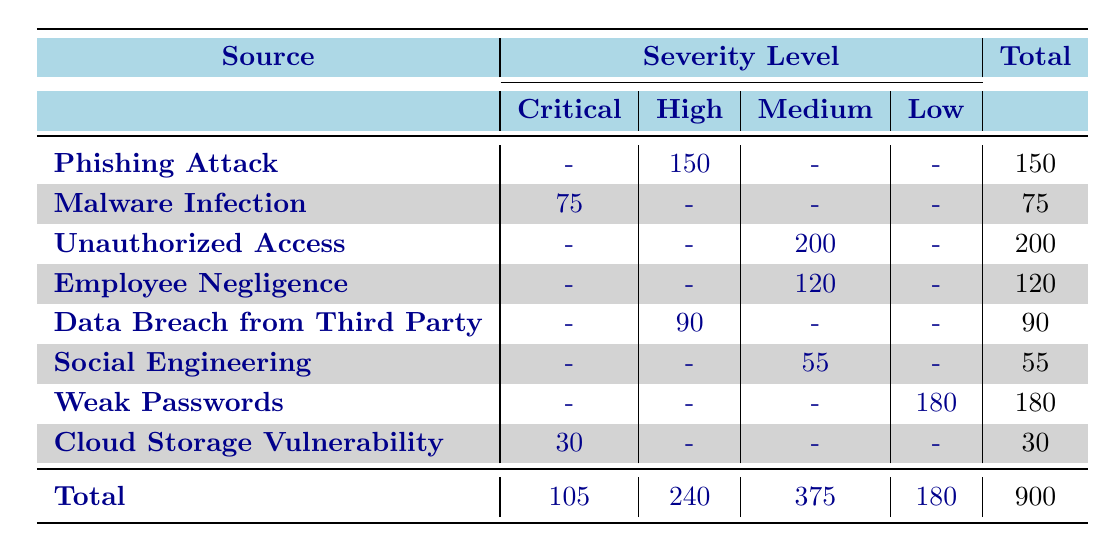What is the total number of privacy breaches listed in the table? To find the total number of privacy breaches, we look at the "Total" column at the bottom of the table, which shows the sum of all breaches across all sources and severity levels. The total given is 900.
Answer: 900 Which source has the highest number of breaches categorized as 'High' severity? We can check the "High" severity column to find the sources listed. Phishing Attack shows 150 breaches, while Data Breach from Third Party shows 90. Since 150 is higher than 90, Phishing Attack has the most breaches at this severity level.
Answer: Phishing Attack Is there a source that has 'Critical' severity breaches but no breaches in the 'High' severity category? By looking at the table, we see that Malware Infection has 75 breaches labeled as 'Critical' and no breaches in the 'High' category. Therefore, the statement is true.
Answer: Yes What is the total number of breaches from sources categorized as 'Medium' severity? Adding the values in the 'Medium' severity column, we find Unauthorized Access (200) + Employee Negligence (120) + Social Engineering (55) = 375. Thus, the total number of 'Medium' severity breaches is 375.
Answer: 375 Are there more breaches from 'Weak Passwords' compared to the sum of breaches from 'Cloud Storage Vulnerability' and 'Malware Infection'? The total for Weak Passwords is 180, while Cloud Storage Vulnerability has 30 and Malware Infection has 75, which totals 30 + 75 = 105. Since 180 is greater than 105, the statement is true.
Answer: Yes How many total 'Critical' severity breaches are reported in the table? To find the total 'Critical' severity breaches, we add the values in the 'Critical' column: Malware Infection has 75 and Cloud Storage Vulnerability has 30. So, 75 + 30 equals 105.
Answer: 105 Which severity level has the fewest breaches, and how many are there? We can quickly assess the totals in each severity level column: Critical (105), High (240), Medium (375), and Low (180). The severity level with the fewest is 'Critical', with 105 breaches.
Answer: Critical, 105 Calculate the difference between 'Medium' and 'Low' severity breaches. The total number of 'Medium' severity breaches is 375, and 'Low' severity breaches total to 180. Subtracting these gives us 375 - 180 = 195. Thus, the difference is 195.
Answer: 195 What percentage of total breaches are classified as 'Low' severity? To calculate the percentage, we divide the number of 'Low' severity breaches (180) by the total breaches (900) and multiply by 100. Therefore, (180 / 900) * 100 equals 20%.
Answer: 20% 